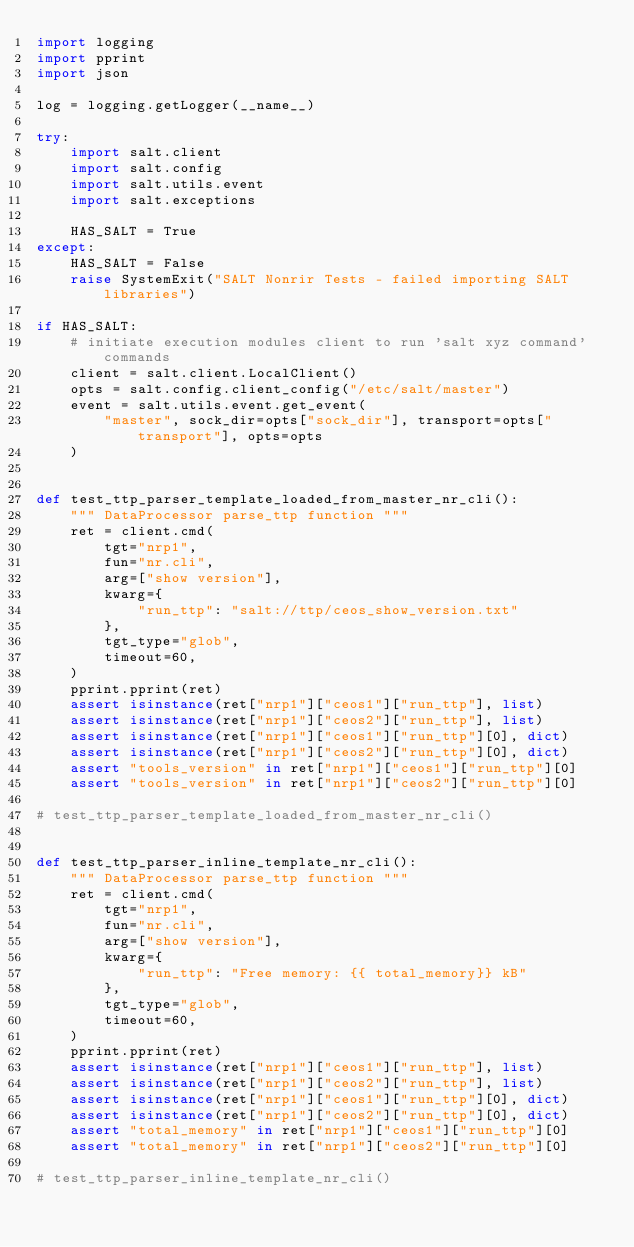<code> <loc_0><loc_0><loc_500><loc_500><_Python_>import logging
import pprint
import json

log = logging.getLogger(__name__)

try:
    import salt.client
    import salt.config
    import salt.utils.event
    import salt.exceptions

    HAS_SALT = True
except:
    HAS_SALT = False
    raise SystemExit("SALT Nonrir Tests - failed importing SALT libraries")

if HAS_SALT:
    # initiate execution modules client to run 'salt xyz command' commands
    client = salt.client.LocalClient()
    opts = salt.config.client_config("/etc/salt/master")
    event = salt.utils.event.get_event(
        "master", sock_dir=opts["sock_dir"], transport=opts["transport"], opts=opts
    )


def test_ttp_parser_template_loaded_from_master_nr_cli():
    """ DataProcessor parse_ttp function """
    ret = client.cmd(
        tgt="nrp1",
        fun="nr.cli",
        arg=["show version"],
        kwarg={
            "run_ttp": "salt://ttp/ceos_show_version.txt"
        },
        tgt_type="glob",
        timeout=60,
    )
    pprint.pprint(ret)
    assert isinstance(ret["nrp1"]["ceos1"]["run_ttp"], list)
    assert isinstance(ret["nrp1"]["ceos2"]["run_ttp"], list)
    assert isinstance(ret["nrp1"]["ceos1"]["run_ttp"][0], dict)
    assert isinstance(ret["nrp1"]["ceos2"]["run_ttp"][0], dict)
    assert "tools_version" in ret["nrp1"]["ceos1"]["run_ttp"][0]
    assert "tools_version" in ret["nrp1"]["ceos2"]["run_ttp"][0]
    
# test_ttp_parser_template_loaded_from_master_nr_cli()


def test_ttp_parser_inline_template_nr_cli():
    """ DataProcessor parse_ttp function """
    ret = client.cmd(
        tgt="nrp1",
        fun="nr.cli",
        arg=["show version"],
        kwarg={
            "run_ttp": "Free memory: {{ total_memory}} kB"
        },
        tgt_type="glob",
        timeout=60,
    )
    pprint.pprint(ret)
    assert isinstance(ret["nrp1"]["ceos1"]["run_ttp"], list)
    assert isinstance(ret["nrp1"]["ceos2"]["run_ttp"], list)
    assert isinstance(ret["nrp1"]["ceos1"]["run_ttp"][0], dict)
    assert isinstance(ret["nrp1"]["ceos2"]["run_ttp"][0], dict)
    assert "total_memory" in ret["nrp1"]["ceos1"]["run_ttp"][0]
    assert "total_memory" in ret["nrp1"]["ceos2"]["run_ttp"][0]
    
# test_ttp_parser_inline_template_nr_cli()</code> 